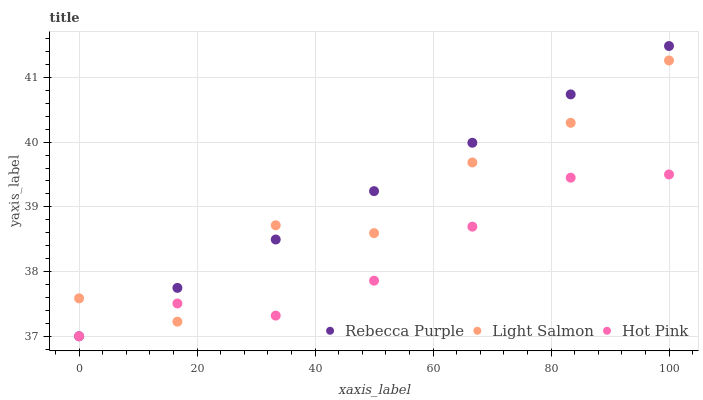Does Hot Pink have the minimum area under the curve?
Answer yes or no. Yes. Does Rebecca Purple have the maximum area under the curve?
Answer yes or no. Yes. Does Rebecca Purple have the minimum area under the curve?
Answer yes or no. No. Does Hot Pink have the maximum area under the curve?
Answer yes or no. No. Is Rebecca Purple the smoothest?
Answer yes or no. Yes. Is Light Salmon the roughest?
Answer yes or no. Yes. Is Hot Pink the smoothest?
Answer yes or no. No. Is Hot Pink the roughest?
Answer yes or no. No. Does Hot Pink have the lowest value?
Answer yes or no. Yes. Does Rebecca Purple have the highest value?
Answer yes or no. Yes. Does Hot Pink have the highest value?
Answer yes or no. No. Does Light Salmon intersect Hot Pink?
Answer yes or no. Yes. Is Light Salmon less than Hot Pink?
Answer yes or no. No. Is Light Salmon greater than Hot Pink?
Answer yes or no. No. 